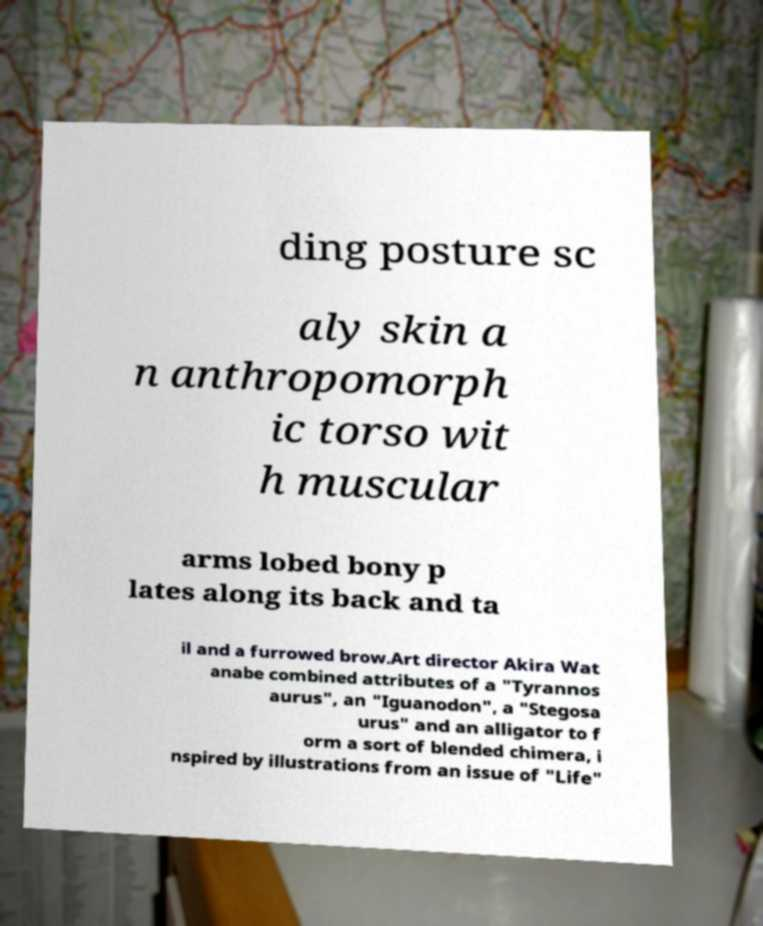There's text embedded in this image that I need extracted. Can you transcribe it verbatim? ding posture sc aly skin a n anthropomorph ic torso wit h muscular arms lobed bony p lates along its back and ta il and a furrowed brow.Art director Akira Wat anabe combined attributes of a "Tyrannos aurus", an "Iguanodon", a "Stegosa urus" and an alligator to f orm a sort of blended chimera, i nspired by illustrations from an issue of "Life" 